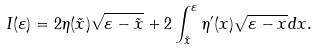Convert formula to latex. <formula><loc_0><loc_0><loc_500><loc_500>I ( \varepsilon ) = 2 \eta ( \tilde { x } ) \sqrt { \varepsilon - \tilde { x } } + 2 \int ^ { \varepsilon } _ { \tilde { x } } \eta ^ { \prime } ( x ) \sqrt { \varepsilon - x } d x .</formula> 